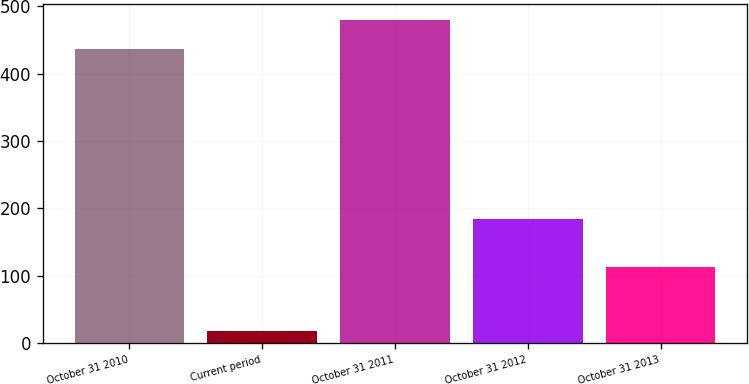<chart> <loc_0><loc_0><loc_500><loc_500><bar_chart><fcel>October 31 2010<fcel>Current period<fcel>October 31 2011<fcel>October 31 2012<fcel>October 31 2013<nl><fcel>436<fcel>18<fcel>479.6<fcel>184<fcel>113<nl></chart> 